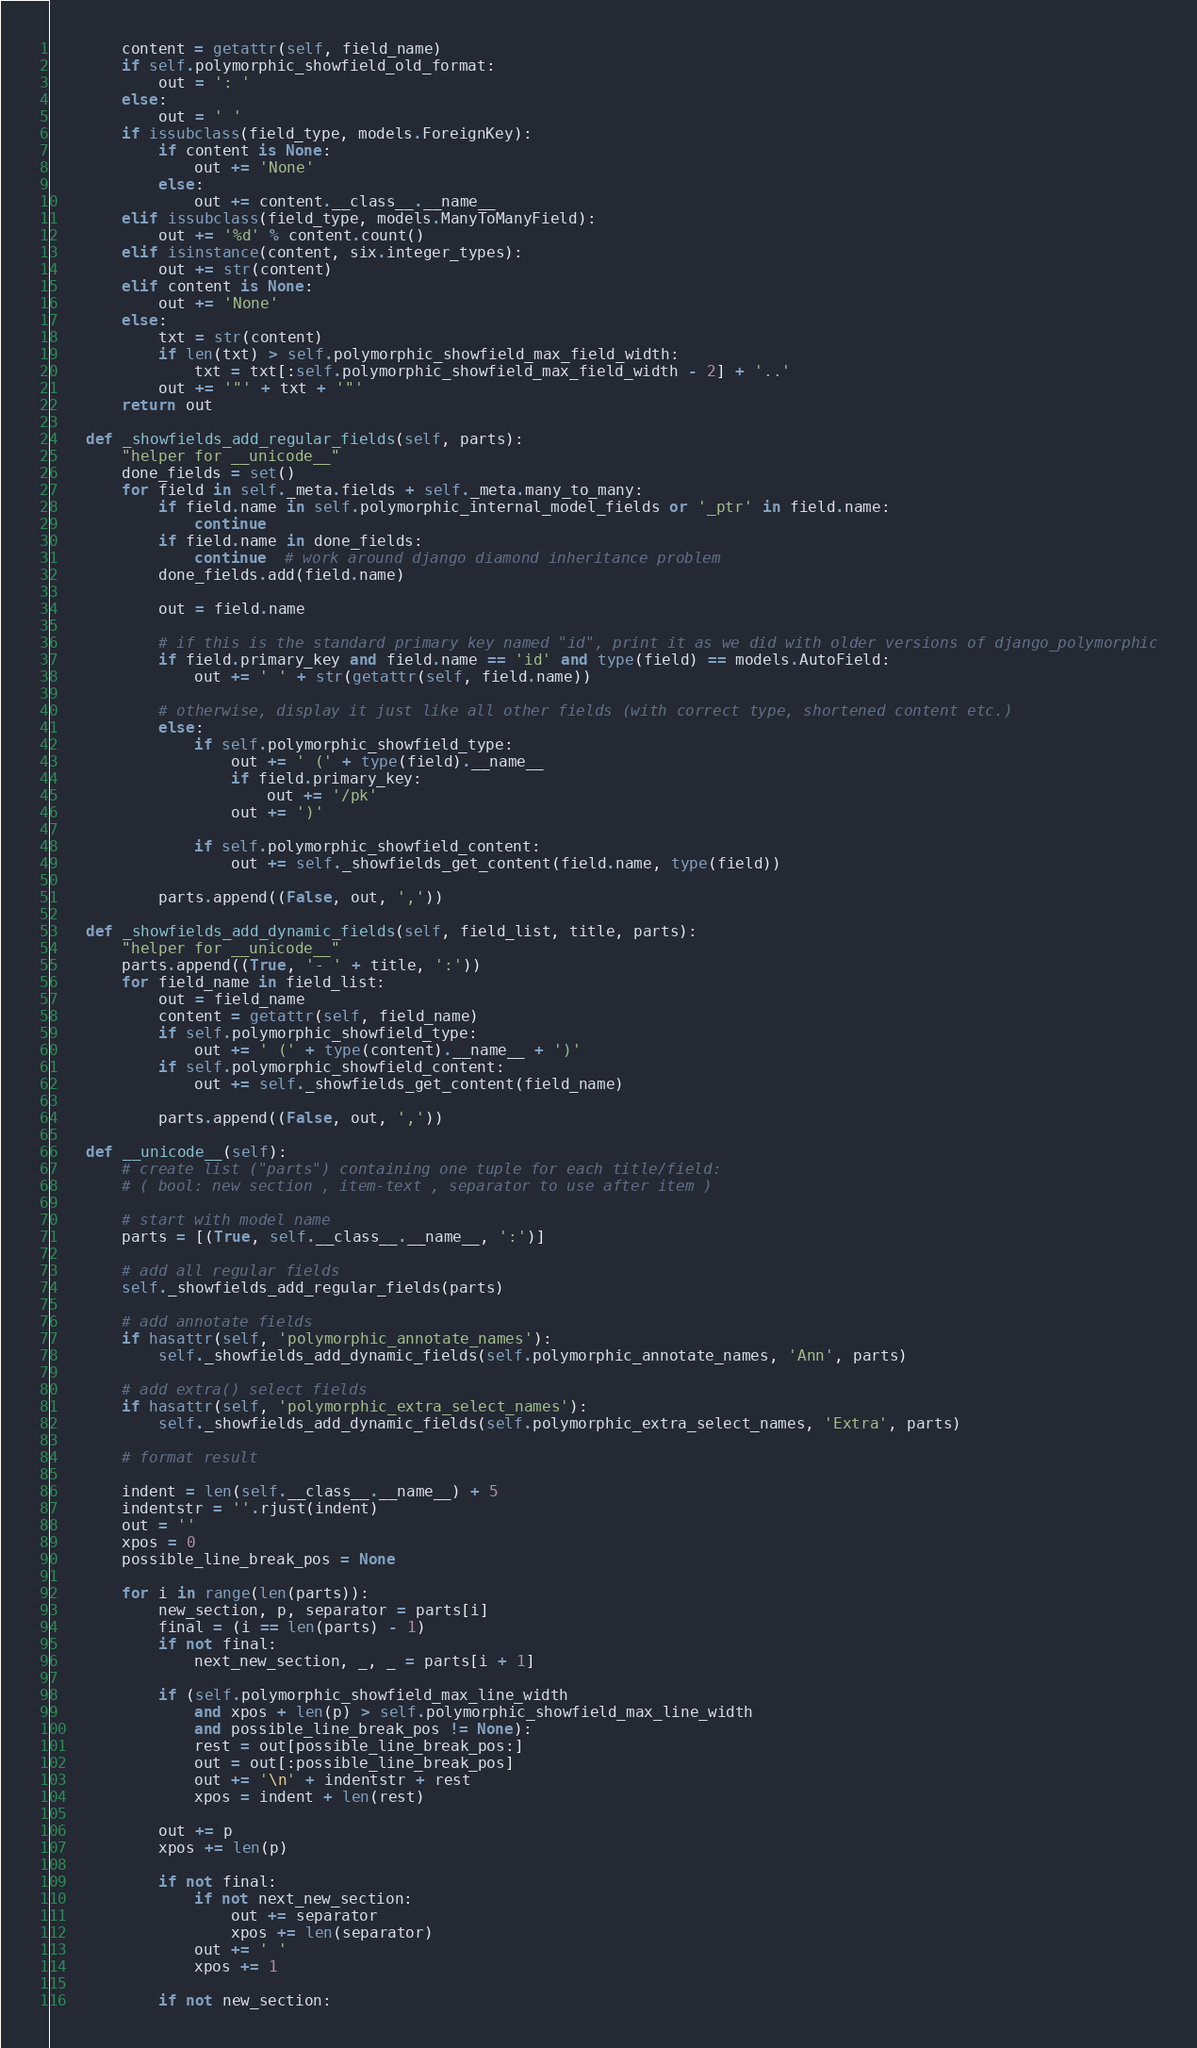<code> <loc_0><loc_0><loc_500><loc_500><_Python_>        content = getattr(self, field_name)
        if self.polymorphic_showfield_old_format:
            out = ': '
        else:
            out = ' '
        if issubclass(field_type, models.ForeignKey):
            if content is None:
                out += 'None'
            else:
                out += content.__class__.__name__
        elif issubclass(field_type, models.ManyToManyField):
            out += '%d' % content.count()
        elif isinstance(content, six.integer_types):
            out += str(content)
        elif content is None:
            out += 'None'
        else:
            txt = str(content)
            if len(txt) > self.polymorphic_showfield_max_field_width:
                txt = txt[:self.polymorphic_showfield_max_field_width - 2] + '..'
            out += '"' + txt + '"'
        return out

    def _showfields_add_regular_fields(self, parts):
        "helper for __unicode__"
        done_fields = set()
        for field in self._meta.fields + self._meta.many_to_many:
            if field.name in self.polymorphic_internal_model_fields or '_ptr' in field.name:
                continue
            if field.name in done_fields:
                continue  # work around django diamond inheritance problem
            done_fields.add(field.name)

            out = field.name

            # if this is the standard primary key named "id", print it as we did with older versions of django_polymorphic
            if field.primary_key and field.name == 'id' and type(field) == models.AutoField:
                out += ' ' + str(getattr(self, field.name))

            # otherwise, display it just like all other fields (with correct type, shortened content etc.)
            else:
                if self.polymorphic_showfield_type:
                    out += ' (' + type(field).__name__
                    if field.primary_key:
                        out += '/pk'
                    out += ')'

                if self.polymorphic_showfield_content:
                    out += self._showfields_get_content(field.name, type(field))

            parts.append((False, out, ','))

    def _showfields_add_dynamic_fields(self, field_list, title, parts):
        "helper for __unicode__"
        parts.append((True, '- ' + title, ':'))
        for field_name in field_list:
            out = field_name
            content = getattr(self, field_name)
            if self.polymorphic_showfield_type:
                out += ' (' + type(content).__name__ + ')'
            if self.polymorphic_showfield_content:
                out += self._showfields_get_content(field_name)

            parts.append((False, out, ','))

    def __unicode__(self):
        # create list ("parts") containing one tuple for each title/field:
        # ( bool: new section , item-text , separator to use after item )

        # start with model name
        parts = [(True, self.__class__.__name__, ':')]

        # add all regular fields
        self._showfields_add_regular_fields(parts)

        # add annotate fields
        if hasattr(self, 'polymorphic_annotate_names'):
            self._showfields_add_dynamic_fields(self.polymorphic_annotate_names, 'Ann', parts)

        # add extra() select fields
        if hasattr(self, 'polymorphic_extra_select_names'):
            self._showfields_add_dynamic_fields(self.polymorphic_extra_select_names, 'Extra', parts)

        # format result

        indent = len(self.__class__.__name__) + 5
        indentstr = ''.rjust(indent)
        out = ''
        xpos = 0
        possible_line_break_pos = None

        for i in range(len(parts)):
            new_section, p, separator = parts[i]
            final = (i == len(parts) - 1)
            if not final:
                next_new_section, _, _ = parts[i + 1]

            if (self.polymorphic_showfield_max_line_width
                and xpos + len(p) > self.polymorphic_showfield_max_line_width
                and possible_line_break_pos != None):
                rest = out[possible_line_break_pos:]
                out = out[:possible_line_break_pos]
                out += '\n' + indentstr + rest
                xpos = indent + len(rest)

            out += p
            xpos += len(p)

            if not final:
                if not next_new_section:
                    out += separator
                    xpos += len(separator)
                out += ' '
                xpos += 1

            if not new_section:</code> 